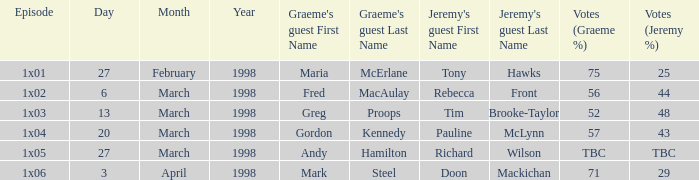What is First Broadcast, when Jeremy's Guest is "Tim Brooke-Taylor"? 13 March 1998. 